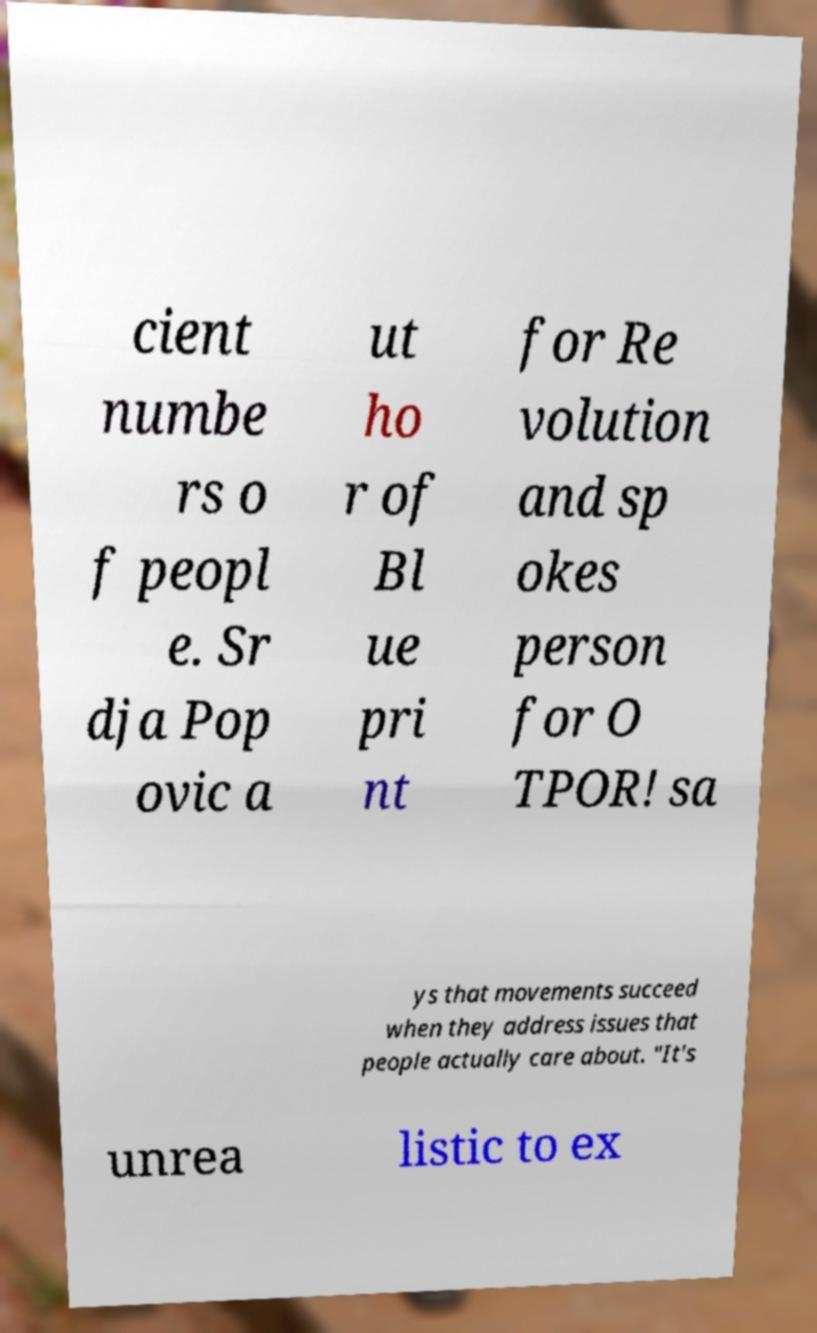Could you assist in decoding the text presented in this image and type it out clearly? cient numbe rs o f peopl e. Sr dja Pop ovic a ut ho r of Bl ue pri nt for Re volution and sp okes person for O TPOR! sa ys that movements succeed when they address issues that people actually care about. "It's unrea listic to ex 